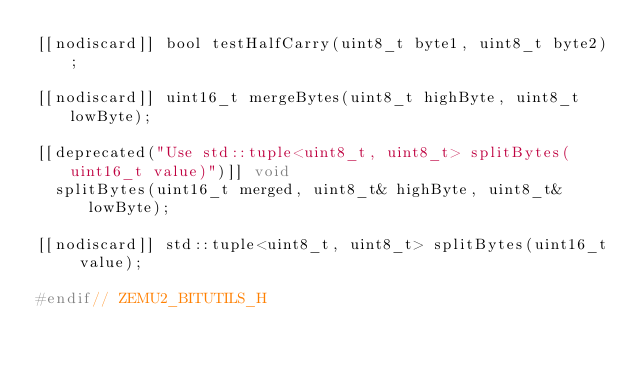Convert code to text. <code><loc_0><loc_0><loc_500><loc_500><_C_>[[nodiscard]] bool testHalfCarry(uint8_t byte1, uint8_t byte2);

[[nodiscard]] uint16_t mergeBytes(uint8_t highByte, uint8_t lowByte);

[[deprecated("Use std::tuple<uint8_t, uint8_t> splitBytes(uint16_t value)")]] void
  splitBytes(uint16_t merged, uint8_t& highByte, uint8_t& lowByte);

[[nodiscard]] std::tuple<uint8_t, uint8_t> splitBytes(uint16_t value);

#endif// ZEMU2_BITUTILS_H
</code> 